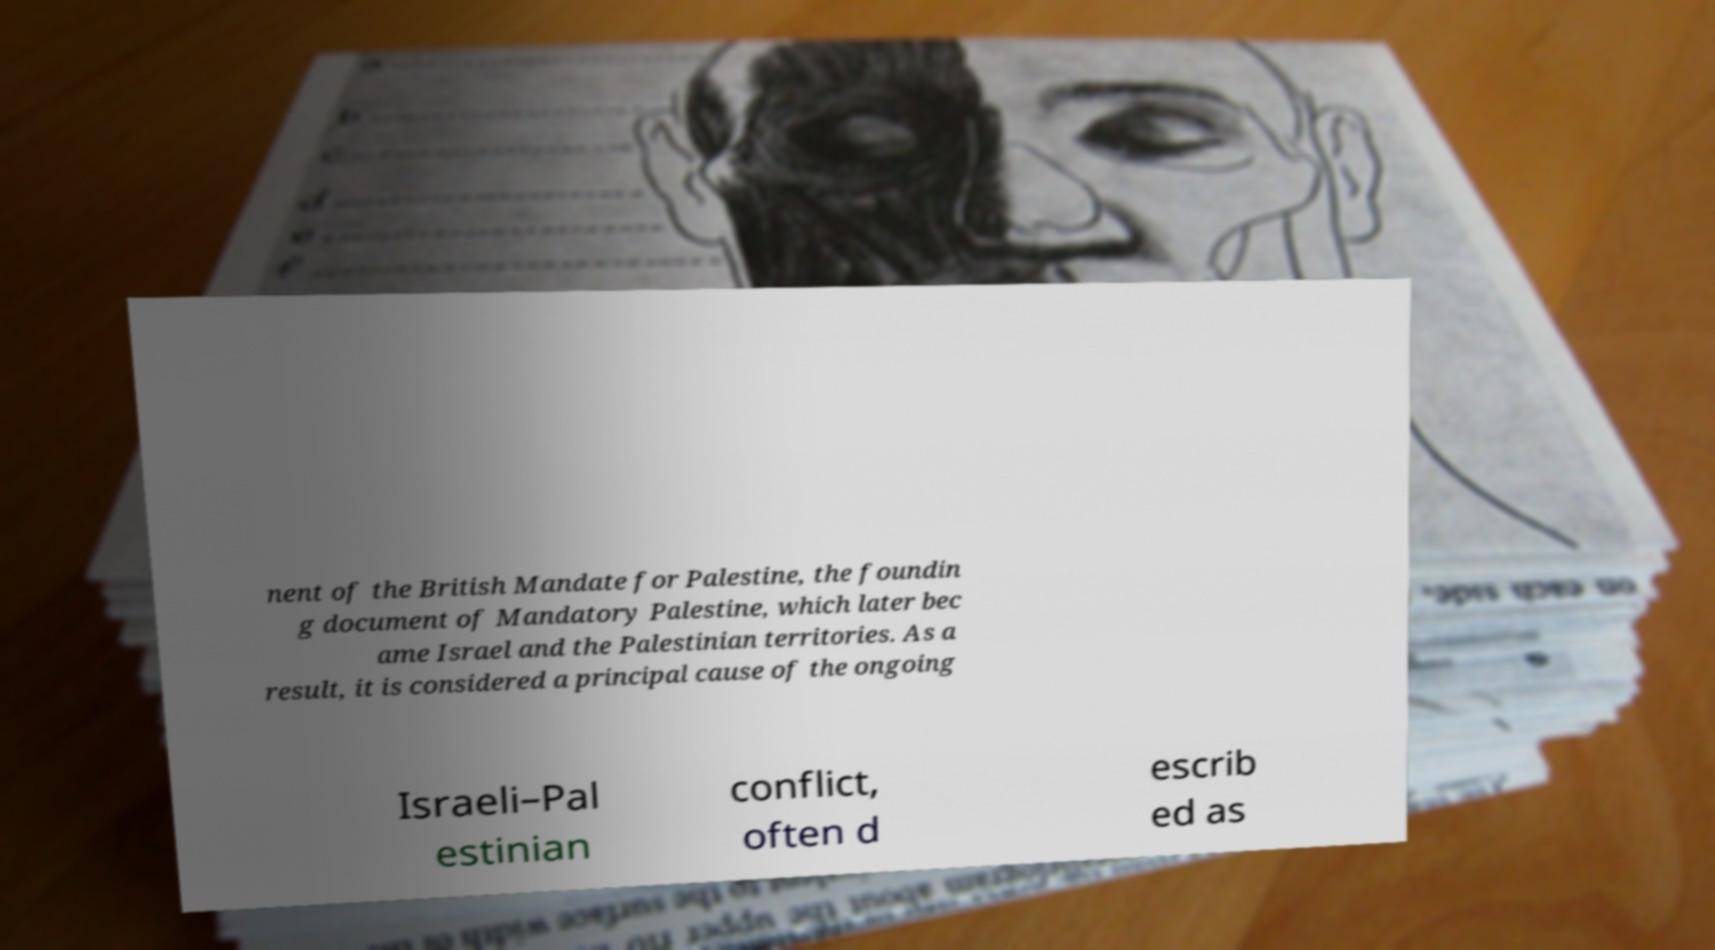I need the written content from this picture converted into text. Can you do that? nent of the British Mandate for Palestine, the foundin g document of Mandatory Palestine, which later bec ame Israel and the Palestinian territories. As a result, it is considered a principal cause of the ongoing Israeli–Pal estinian conflict, often d escrib ed as 